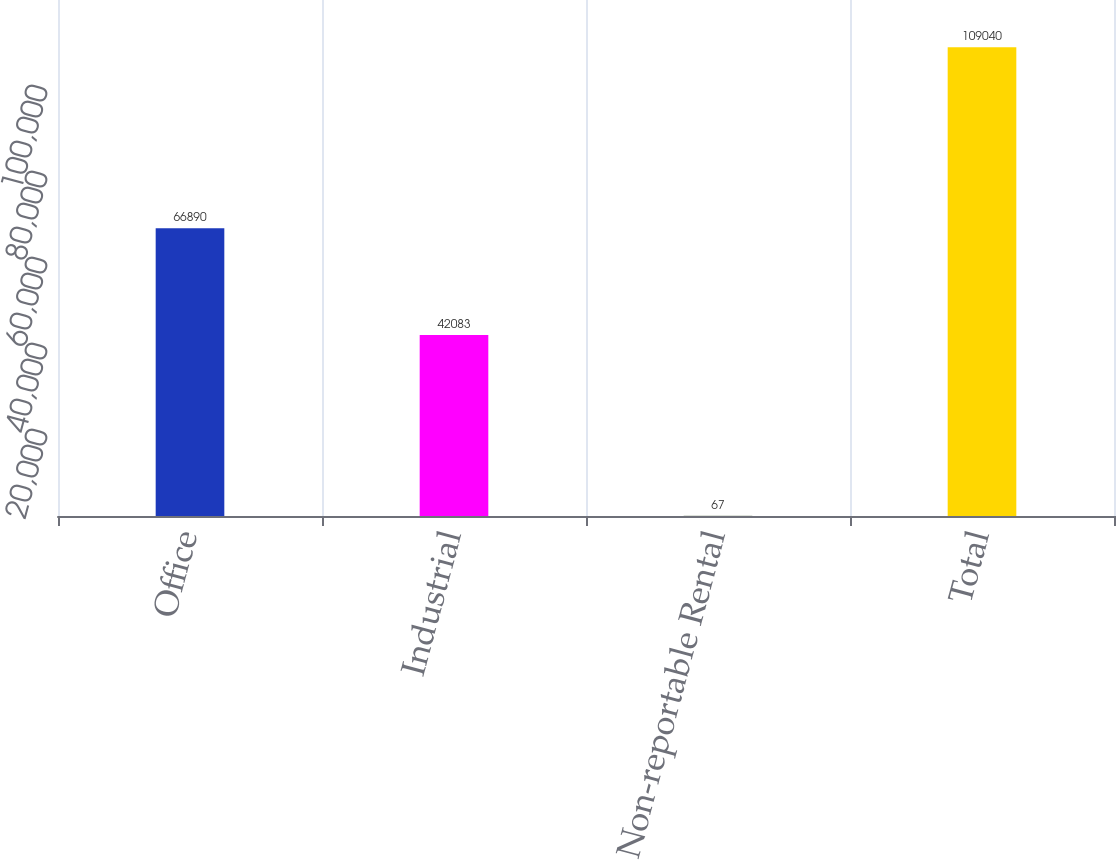Convert chart to OTSL. <chart><loc_0><loc_0><loc_500><loc_500><bar_chart><fcel>Office<fcel>Industrial<fcel>Non-reportable Rental<fcel>Total<nl><fcel>66890<fcel>42083<fcel>67<fcel>109040<nl></chart> 